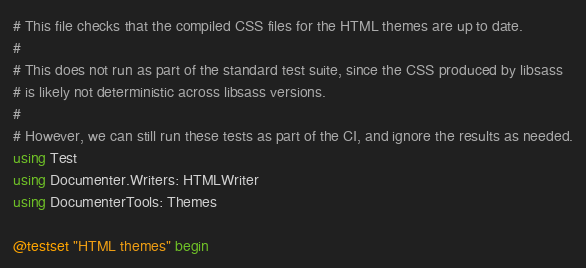<code> <loc_0><loc_0><loc_500><loc_500><_Julia_># This file checks that the compiled CSS files for the HTML themes are up to date.
#
# This does not run as part of the standard test suite, since the CSS produced by libsass
# is likely not deterministic across libsass versions.
#
# However, we can still run these tests as part of the CI, and ignore the results as needed.
using Test
using Documenter.Writers: HTMLWriter
using DocumenterTools: Themes

@testset "HTML themes" begin</code> 